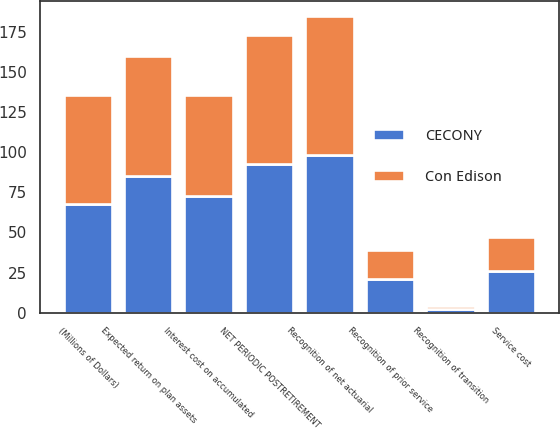Convert chart to OTSL. <chart><loc_0><loc_0><loc_500><loc_500><stacked_bar_chart><ecel><fcel>(Millions of Dollars)<fcel>Service cost<fcel>Interest cost on accumulated<fcel>Expected return on plan assets<fcel>Recognition of net actuarial<fcel>Recognition of prior service<fcel>Recognition of transition<fcel>NET PERIODIC POSTRETIREMENT<nl><fcel>CECONY<fcel>68<fcel>26<fcel>73<fcel>85<fcel>98<fcel>21<fcel>2<fcel>93<nl><fcel>Con Edison<fcel>68<fcel>21<fcel>63<fcel>75<fcel>87<fcel>18<fcel>2<fcel>80<nl></chart> 